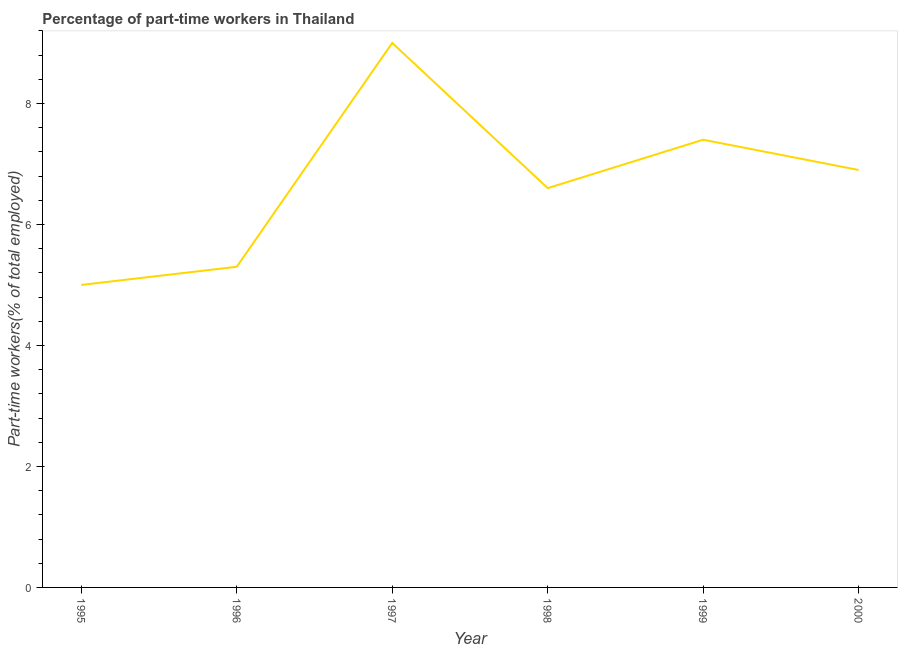Across all years, what is the maximum percentage of part-time workers?
Provide a succinct answer. 9. In which year was the percentage of part-time workers minimum?
Make the answer very short. 1995. What is the sum of the percentage of part-time workers?
Offer a terse response. 40.2. What is the difference between the percentage of part-time workers in 1998 and 1999?
Give a very brief answer. -0.8. What is the average percentage of part-time workers per year?
Your answer should be compact. 6.7. What is the median percentage of part-time workers?
Offer a very short reply. 6.75. What is the ratio of the percentage of part-time workers in 1995 to that in 1998?
Ensure brevity in your answer.  0.76. Is the difference between the percentage of part-time workers in 1996 and 1998 greater than the difference between any two years?
Keep it short and to the point. No. What is the difference between the highest and the second highest percentage of part-time workers?
Offer a very short reply. 1.6. In how many years, is the percentage of part-time workers greater than the average percentage of part-time workers taken over all years?
Your answer should be compact. 3. How many lines are there?
Provide a short and direct response. 1. What is the difference between two consecutive major ticks on the Y-axis?
Make the answer very short. 2. Does the graph contain any zero values?
Offer a terse response. No. Does the graph contain grids?
Make the answer very short. No. What is the title of the graph?
Your answer should be very brief. Percentage of part-time workers in Thailand. What is the label or title of the Y-axis?
Your response must be concise. Part-time workers(% of total employed). What is the Part-time workers(% of total employed) in 1996?
Give a very brief answer. 5.3. What is the Part-time workers(% of total employed) in 1998?
Provide a short and direct response. 6.6. What is the Part-time workers(% of total employed) of 1999?
Keep it short and to the point. 7.4. What is the Part-time workers(% of total employed) in 2000?
Make the answer very short. 6.9. What is the difference between the Part-time workers(% of total employed) in 1995 and 1996?
Keep it short and to the point. -0.3. What is the difference between the Part-time workers(% of total employed) in 1995 and 1997?
Your answer should be very brief. -4. What is the difference between the Part-time workers(% of total employed) in 1996 and 1998?
Your answer should be compact. -1.3. What is the difference between the Part-time workers(% of total employed) in 1996 and 1999?
Your response must be concise. -2.1. What is the difference between the Part-time workers(% of total employed) in 1997 and 1999?
Your response must be concise. 1.6. What is the difference between the Part-time workers(% of total employed) in 1998 and 1999?
Provide a short and direct response. -0.8. What is the ratio of the Part-time workers(% of total employed) in 1995 to that in 1996?
Make the answer very short. 0.94. What is the ratio of the Part-time workers(% of total employed) in 1995 to that in 1997?
Your answer should be compact. 0.56. What is the ratio of the Part-time workers(% of total employed) in 1995 to that in 1998?
Keep it short and to the point. 0.76. What is the ratio of the Part-time workers(% of total employed) in 1995 to that in 1999?
Ensure brevity in your answer.  0.68. What is the ratio of the Part-time workers(% of total employed) in 1995 to that in 2000?
Your answer should be compact. 0.72. What is the ratio of the Part-time workers(% of total employed) in 1996 to that in 1997?
Provide a succinct answer. 0.59. What is the ratio of the Part-time workers(% of total employed) in 1996 to that in 1998?
Offer a very short reply. 0.8. What is the ratio of the Part-time workers(% of total employed) in 1996 to that in 1999?
Provide a short and direct response. 0.72. What is the ratio of the Part-time workers(% of total employed) in 1996 to that in 2000?
Ensure brevity in your answer.  0.77. What is the ratio of the Part-time workers(% of total employed) in 1997 to that in 1998?
Offer a terse response. 1.36. What is the ratio of the Part-time workers(% of total employed) in 1997 to that in 1999?
Offer a very short reply. 1.22. What is the ratio of the Part-time workers(% of total employed) in 1997 to that in 2000?
Offer a very short reply. 1.3. What is the ratio of the Part-time workers(% of total employed) in 1998 to that in 1999?
Your answer should be very brief. 0.89. What is the ratio of the Part-time workers(% of total employed) in 1998 to that in 2000?
Your response must be concise. 0.96. What is the ratio of the Part-time workers(% of total employed) in 1999 to that in 2000?
Offer a very short reply. 1.07. 